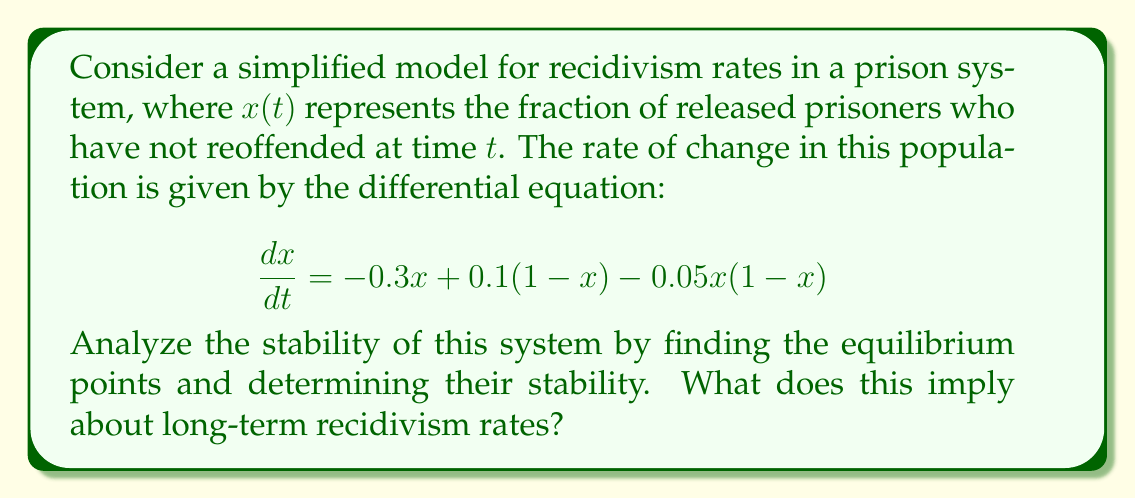Help me with this question. 1) First, we need to find the equilibrium points by setting $\frac{dx}{dt} = 0$:

   $$-0.3x + 0.1(1-x) - 0.05x(1-x) = 0$$

2) Simplify the equation:
   $$-0.3x + 0.1 - 0.1x - 0.05x + 0.05x^2 = 0$$
   $$0.05x^2 - 0.45x + 0.1 = 0$$

3) This is a quadratic equation. We can solve it using the quadratic formula:
   $$x = \frac{-b \pm \sqrt{b^2 - 4ac}}{2a}$$
   where $a = 0.05$, $b = -0.45$, and $c = 0.1$

4) Solving this:
   $$x = \frac{0.45 \pm \sqrt{0.2025 - 0.02}}{0.1} = \frac{0.45 \pm \sqrt{0.1825}}{0.1}$$
   $$x \approx 0.2378 \text{ or } 8.4622$$

5) Since $x$ represents a fraction, we discard the solution greater than 1. So our equilibrium point is $x^* \approx 0.2378$.

6) To determine stability, we evaluate the derivative of $\frac{dx}{dt}$ with respect to $x$ at the equilibrium point:

   $$\frac{d}{dx}(\frac{dx}{dt}) = -0.3 - 0.1 - 0.05 + 0.1x = -0.45 + 0.1x$$

7) At $x^* \approx 0.2378$:
   $$-0.45 + 0.1(0.2378) \approx -0.4262 < 0$$

8) Since this derivative is negative at the equilibrium point, the equilibrium is stable.

This implies that, in the long term, approximately 23.78% of released prisoners will not reoffend, while about 76.22% will reoffend. The stability of this equilibrium suggests that, without significant changes to the system, these rates will tend to persist over time.
Answer: Stable equilibrium at $x^* \approx 0.2378$, implying a long-term recidivism rate of about 76.22%. 